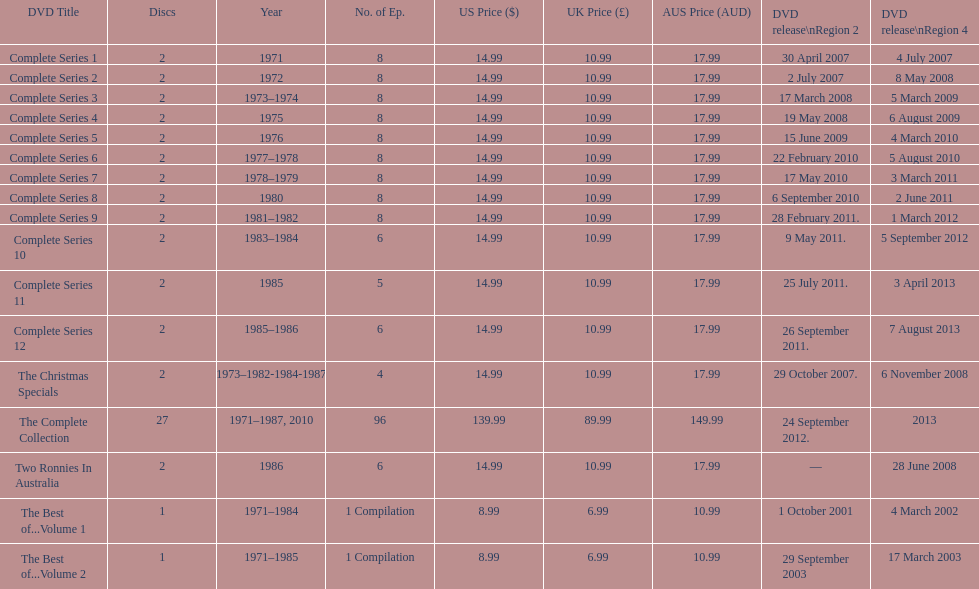What is previous to complete series 10? Complete Series 9. 